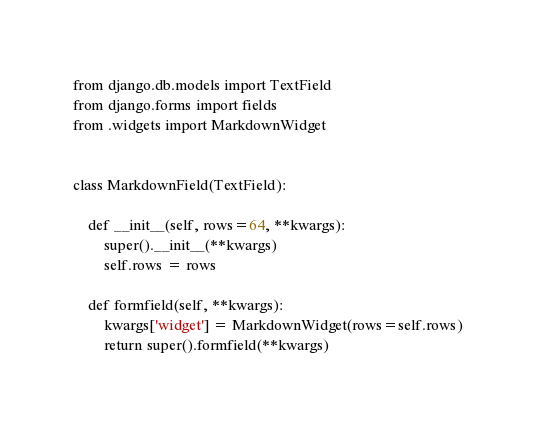<code> <loc_0><loc_0><loc_500><loc_500><_Python_>from django.db.models import TextField
from django.forms import fields
from .widgets import MarkdownWidget


class MarkdownField(TextField):

    def __init__(self, rows=64, **kwargs):
        super().__init__(**kwargs)
        self.rows = rows

    def formfield(self, **kwargs):
        kwargs['widget'] = MarkdownWidget(rows=self.rows)
        return super().formfield(**kwargs)
</code> 